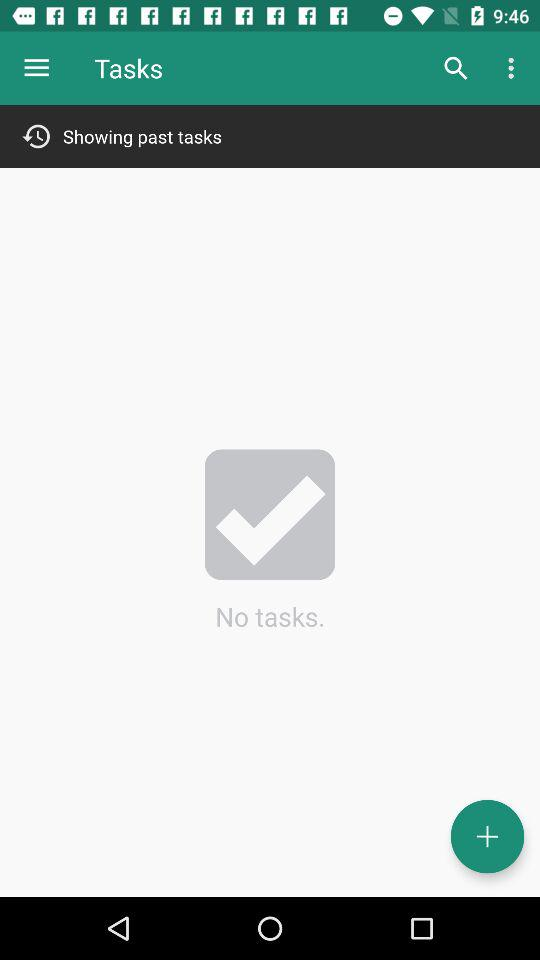How many tasks are there?
Answer the question using a single word or phrase. 0 